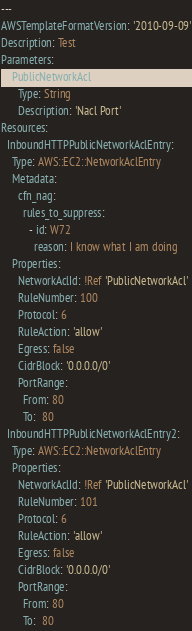<code> <loc_0><loc_0><loc_500><loc_500><_YAML_>---
AWSTemplateFormatVersion: '2010-09-09'
Description: Test
Parameters:
    PublicNetworkAcl:
      Type: String
      Description: 'Nacl Port'
Resources:
  InboundHTTPPublicNetworkAclEntry:
    Type: AWS::EC2::NetworkAclEntry
    Metadata:
      cfn_nag:
        rules_to_suppress:
          - id: W72
            reason: I know what I am doing
    Properties:
      NetworkAclId: !Ref 'PublicNetworkAcl'
      RuleNumber: 100
      Protocol: 6
      RuleAction: 'allow'
      Egress: false
      CidrBlock: '0.0.0.0/0'
      PortRange:
        From: 80
        To:  80
  InboundHTTPPublicNetworkAclEntry2:
    Type: AWS::EC2::NetworkAclEntry
    Properties:
      NetworkAclId: !Ref 'PublicNetworkAcl'
      RuleNumber: 101
      Protocol: 6
      RuleAction: 'allow'
      Egress: false
      CidrBlock: '0.0.0.0/0'
      PortRange:
        From: 80
        To:  80
</code> 